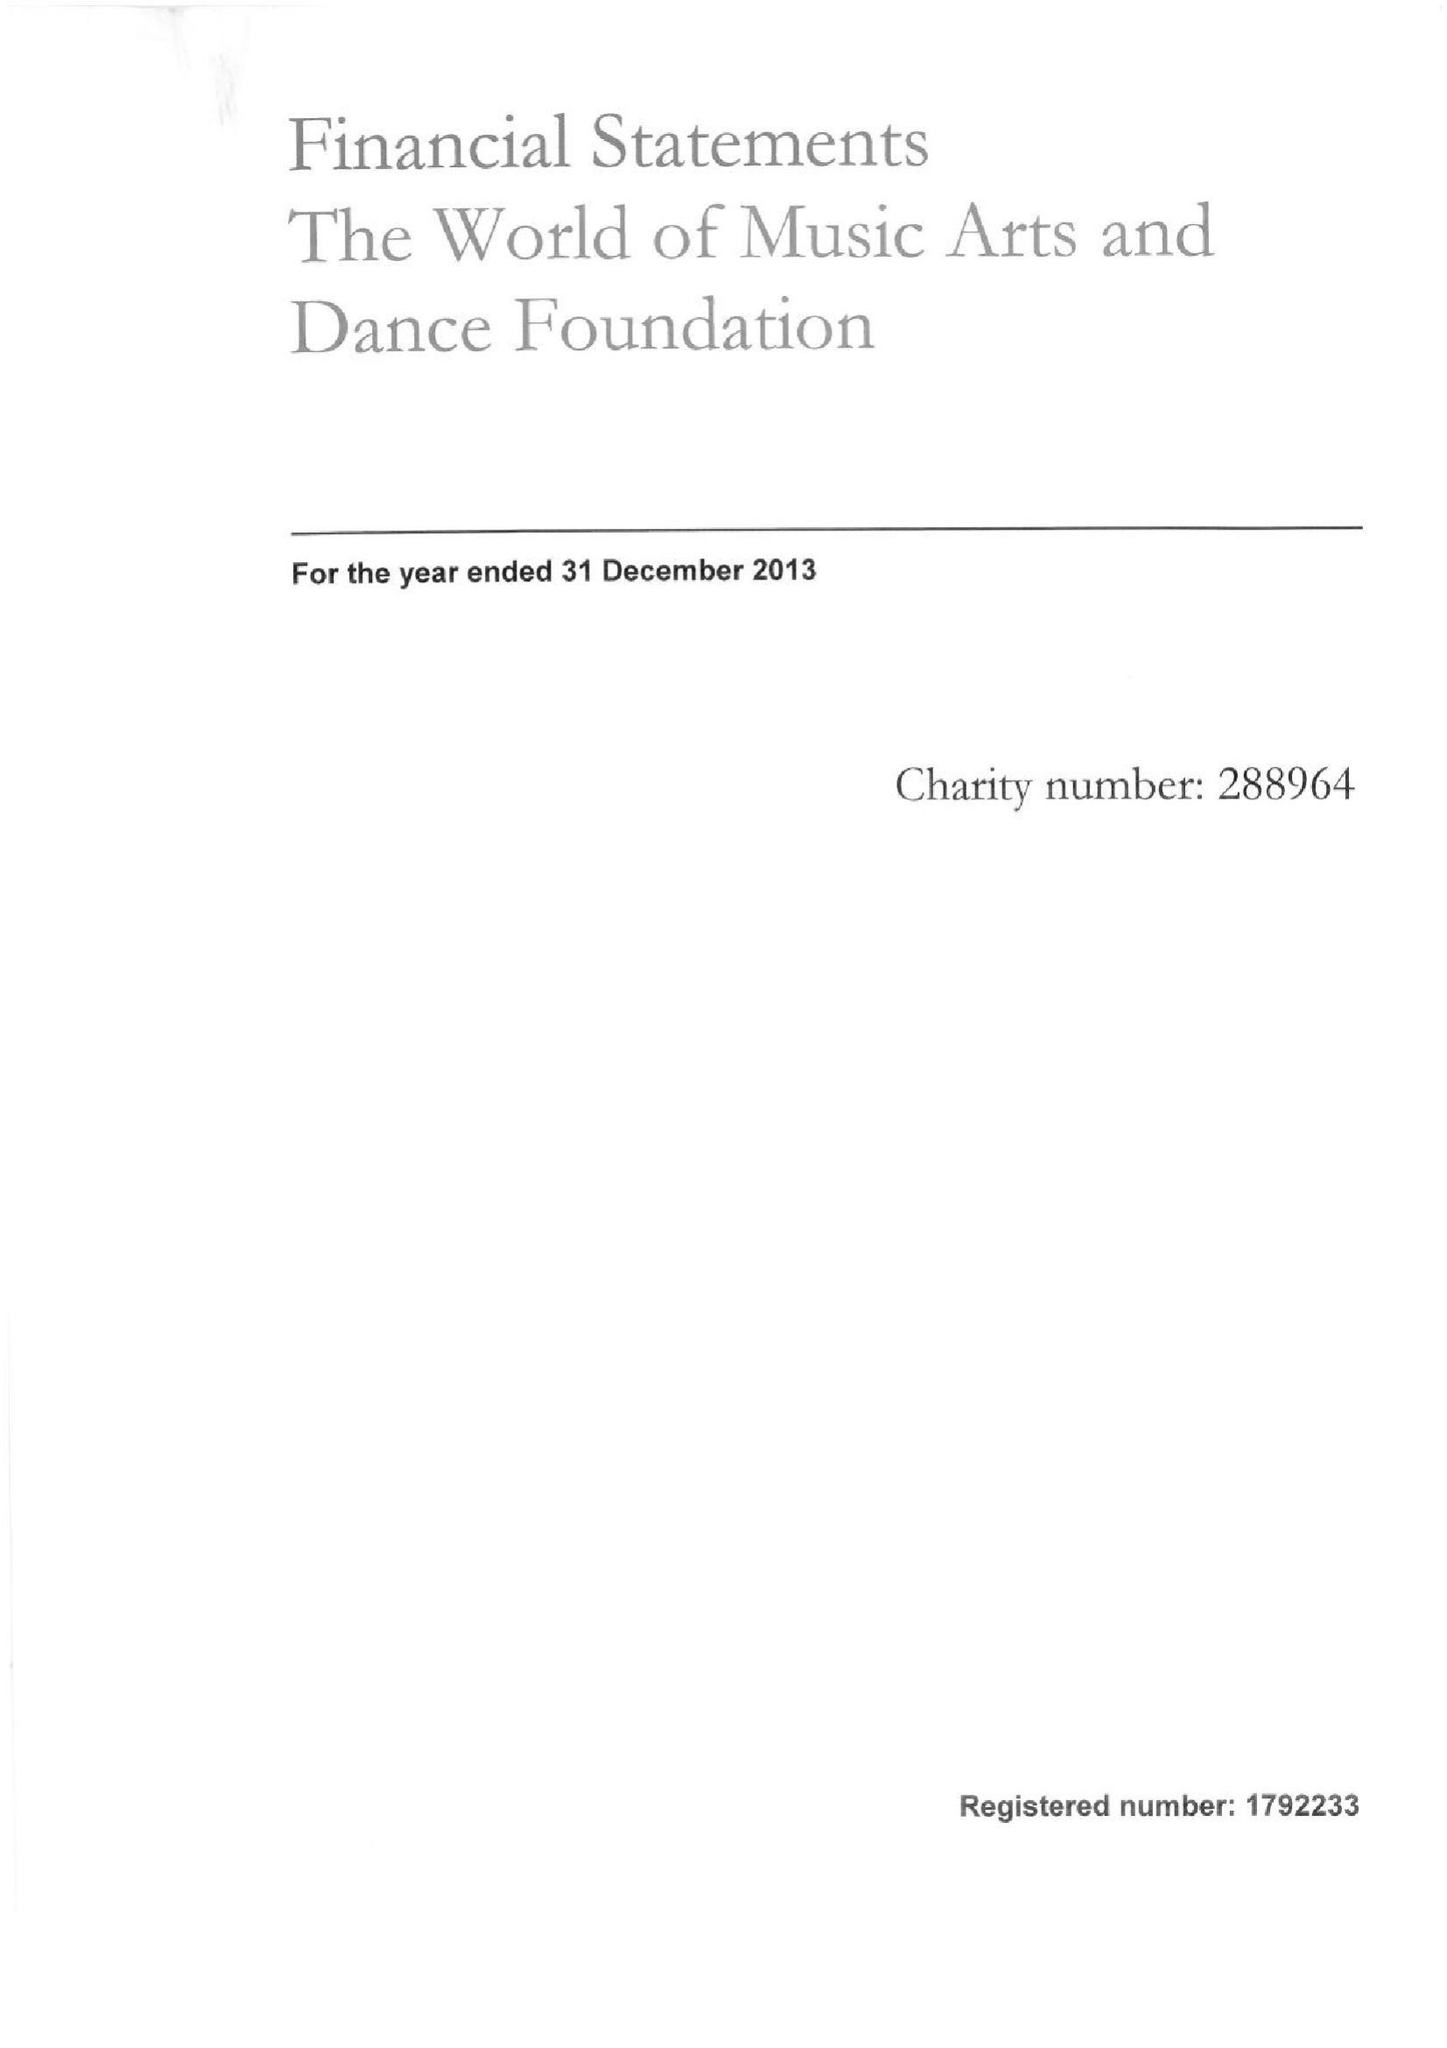What is the value for the income_annually_in_british_pounds?
Answer the question using a single word or phrase. 70648.00 